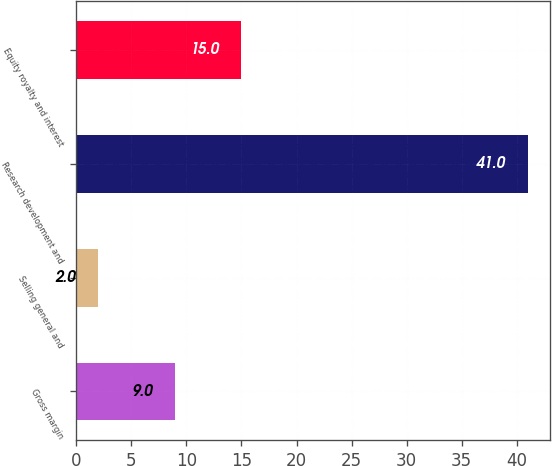Convert chart to OTSL. <chart><loc_0><loc_0><loc_500><loc_500><bar_chart><fcel>Gross margin<fcel>Selling general and<fcel>Research development and<fcel>Equity royalty and interest<nl><fcel>9<fcel>2<fcel>41<fcel>15<nl></chart> 